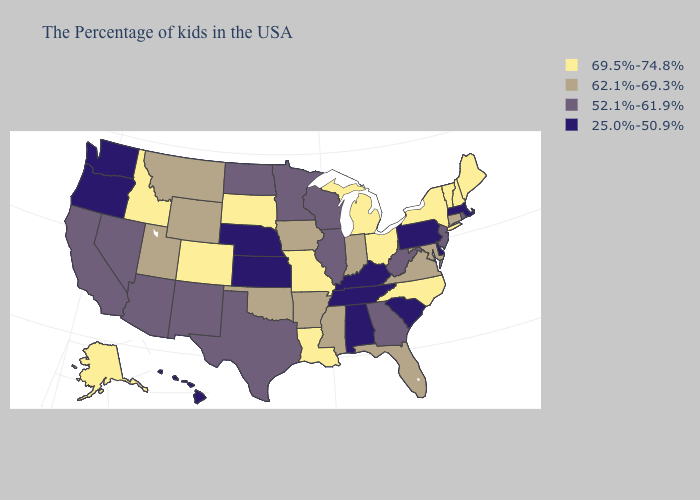What is the highest value in the Northeast ?
Keep it brief. 69.5%-74.8%. Name the states that have a value in the range 52.1%-61.9%?
Short answer required. Rhode Island, New Jersey, West Virginia, Georgia, Wisconsin, Illinois, Minnesota, Texas, North Dakota, New Mexico, Arizona, Nevada, California. Name the states that have a value in the range 69.5%-74.8%?
Short answer required. Maine, New Hampshire, Vermont, New York, North Carolina, Ohio, Michigan, Louisiana, Missouri, South Dakota, Colorado, Idaho, Alaska. Among the states that border Missouri , which have the lowest value?
Give a very brief answer. Kentucky, Tennessee, Kansas, Nebraska. Does the map have missing data?
Concise answer only. No. Does Missouri have a lower value than Iowa?
Be succinct. No. How many symbols are there in the legend?
Answer briefly. 4. Does the map have missing data?
Quick response, please. No. Which states have the lowest value in the MidWest?
Write a very short answer. Kansas, Nebraska. Name the states that have a value in the range 69.5%-74.8%?
Short answer required. Maine, New Hampshire, Vermont, New York, North Carolina, Ohio, Michigan, Louisiana, Missouri, South Dakota, Colorado, Idaho, Alaska. Name the states that have a value in the range 25.0%-50.9%?
Be succinct. Massachusetts, Delaware, Pennsylvania, South Carolina, Kentucky, Alabama, Tennessee, Kansas, Nebraska, Washington, Oregon, Hawaii. What is the highest value in the USA?
Keep it brief. 69.5%-74.8%. Name the states that have a value in the range 69.5%-74.8%?
Keep it brief. Maine, New Hampshire, Vermont, New York, North Carolina, Ohio, Michigan, Louisiana, Missouri, South Dakota, Colorado, Idaho, Alaska. What is the lowest value in the USA?
Keep it brief. 25.0%-50.9%. What is the lowest value in states that border Washington?
Concise answer only. 25.0%-50.9%. 